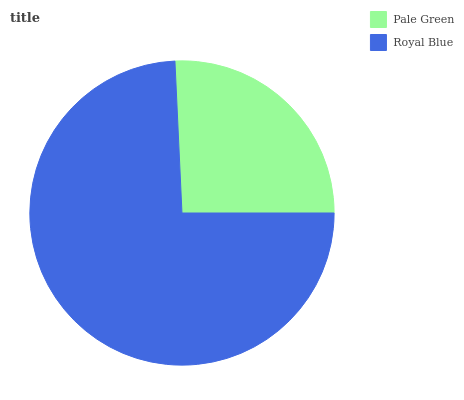Is Pale Green the minimum?
Answer yes or no. Yes. Is Royal Blue the maximum?
Answer yes or no. Yes. Is Royal Blue the minimum?
Answer yes or no. No. Is Royal Blue greater than Pale Green?
Answer yes or no. Yes. Is Pale Green less than Royal Blue?
Answer yes or no. Yes. Is Pale Green greater than Royal Blue?
Answer yes or no. No. Is Royal Blue less than Pale Green?
Answer yes or no. No. Is Royal Blue the high median?
Answer yes or no. Yes. Is Pale Green the low median?
Answer yes or no. Yes. Is Pale Green the high median?
Answer yes or no. No. Is Royal Blue the low median?
Answer yes or no. No. 